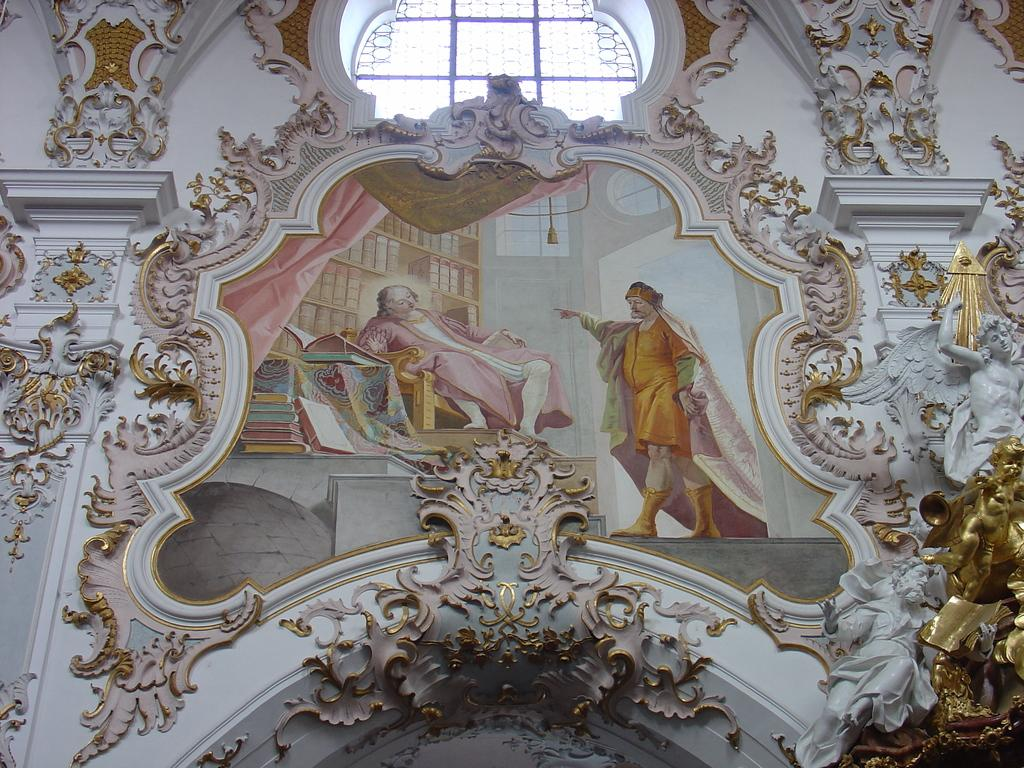What is the main subject in the center of the image? There is a portrait in the center of the image. What type of architectural feature is present at the top side of the image? There is a glass window at the top side of the image. How are the sides of the portrait decorated? The portrait has decorated sides. Can you see any crackers floating in the river in the image? There is no river or crackers present in the image. 